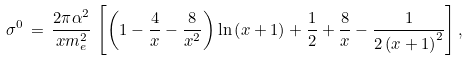<formula> <loc_0><loc_0><loc_500><loc_500>\sigma ^ { 0 } \, = \, \frac { 2 \pi \alpha ^ { 2 } } { x m _ { e } ^ { 2 } } \, \left [ \left ( 1 - \frac { 4 } { x } - \frac { 8 } { x ^ { 2 } } \right ) \ln \left ( x + 1 \right ) + \frac { 1 } { 2 } + \frac { 8 } { x } - \frac { 1 } { 2 \left ( x + 1 \right ) ^ { 2 } } \right ] , \\</formula> 